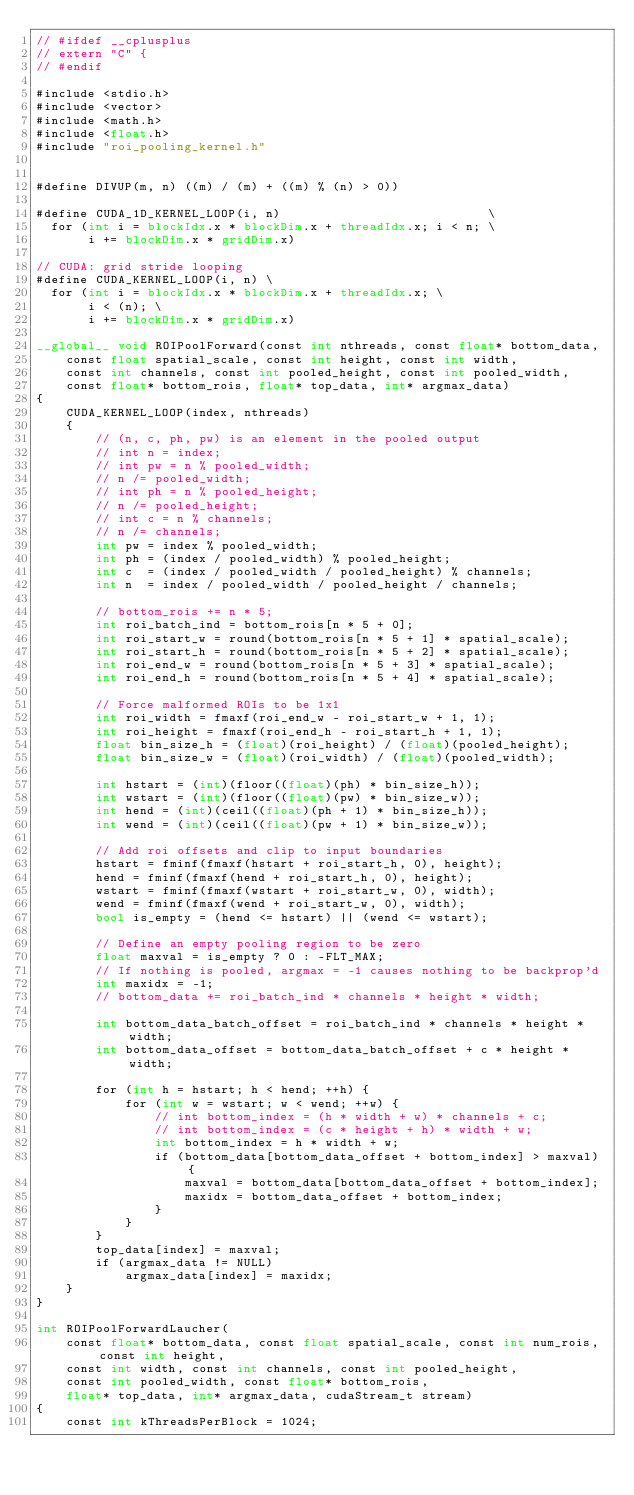Convert code to text. <code><loc_0><loc_0><loc_500><loc_500><_Cuda_>// #ifdef __cplusplus
// extern "C" {
// #endif

#include <stdio.h>
#include <vector>
#include <math.h>
#include <float.h>
#include "roi_pooling_kernel.h"


#define DIVUP(m, n) ((m) / (m) + ((m) % (n) > 0))

#define CUDA_1D_KERNEL_LOOP(i, n)                            \
  for (int i = blockIdx.x * blockDim.x + threadIdx.x; i < n; \
       i += blockDim.x * gridDim.x)

// CUDA: grid stride looping
#define CUDA_KERNEL_LOOP(i, n) \
  for (int i = blockIdx.x * blockDim.x + threadIdx.x; \
       i < (n); \
       i += blockDim.x * gridDim.x)

__global__ void ROIPoolForward(const int nthreads, const float* bottom_data,
    const float spatial_scale, const int height, const int width,
    const int channels, const int pooled_height, const int pooled_width,
    const float* bottom_rois, float* top_data, int* argmax_data)
{
    CUDA_KERNEL_LOOP(index, nthreads)
    {
        // (n, c, ph, pw) is an element in the pooled output
        // int n = index;
        // int pw = n % pooled_width;
        // n /= pooled_width;
        // int ph = n % pooled_height;
        // n /= pooled_height;
        // int c = n % channels;
        // n /= channels;
        int pw = index % pooled_width;
        int ph = (index / pooled_width) % pooled_height;
        int c  = (index / pooled_width / pooled_height) % channels;
        int n  = index / pooled_width / pooled_height / channels;

        // bottom_rois += n * 5;
        int roi_batch_ind = bottom_rois[n * 5 + 0];
        int roi_start_w = round(bottom_rois[n * 5 + 1] * spatial_scale);
        int roi_start_h = round(bottom_rois[n * 5 + 2] * spatial_scale);
        int roi_end_w = round(bottom_rois[n * 5 + 3] * spatial_scale);
        int roi_end_h = round(bottom_rois[n * 5 + 4] * spatial_scale);

        // Force malformed ROIs to be 1x1
        int roi_width = fmaxf(roi_end_w - roi_start_w + 1, 1);
        int roi_height = fmaxf(roi_end_h - roi_start_h + 1, 1);
        float bin_size_h = (float)(roi_height) / (float)(pooled_height);
        float bin_size_w = (float)(roi_width) / (float)(pooled_width);

        int hstart = (int)(floor((float)(ph) * bin_size_h));
        int wstart = (int)(floor((float)(pw) * bin_size_w));
        int hend = (int)(ceil((float)(ph + 1) * bin_size_h));
        int wend = (int)(ceil((float)(pw + 1) * bin_size_w));

        // Add roi offsets and clip to input boundaries
        hstart = fminf(fmaxf(hstart + roi_start_h, 0), height);
        hend = fminf(fmaxf(hend + roi_start_h, 0), height);
        wstart = fminf(fmaxf(wstart + roi_start_w, 0), width);
        wend = fminf(fmaxf(wend + roi_start_w, 0), width);
        bool is_empty = (hend <= hstart) || (wend <= wstart);

        // Define an empty pooling region to be zero
        float maxval = is_empty ? 0 : -FLT_MAX;
        // If nothing is pooled, argmax = -1 causes nothing to be backprop'd
        int maxidx = -1;
        // bottom_data += roi_batch_ind * channels * height * width;

        int bottom_data_batch_offset = roi_batch_ind * channels * height * width;
        int bottom_data_offset = bottom_data_batch_offset + c * height * width;

        for (int h = hstart; h < hend; ++h) {
            for (int w = wstart; w < wend; ++w) {
                // int bottom_index = (h * width + w) * channels + c;
                // int bottom_index = (c * height + h) * width + w;
                int bottom_index = h * width + w;
                if (bottom_data[bottom_data_offset + bottom_index] > maxval) {
                    maxval = bottom_data[bottom_data_offset + bottom_index];
                    maxidx = bottom_data_offset + bottom_index;
                }
            }
        }
        top_data[index] = maxval;
        if (argmax_data != NULL)
            argmax_data[index] = maxidx;
    }
}

int ROIPoolForwardLaucher(
    const float* bottom_data, const float spatial_scale, const int num_rois, const int height,
    const int width, const int channels, const int pooled_height,
    const int pooled_width, const float* bottom_rois,
    float* top_data, int* argmax_data, cudaStream_t stream)
{
    const int kThreadsPerBlock = 1024;</code> 